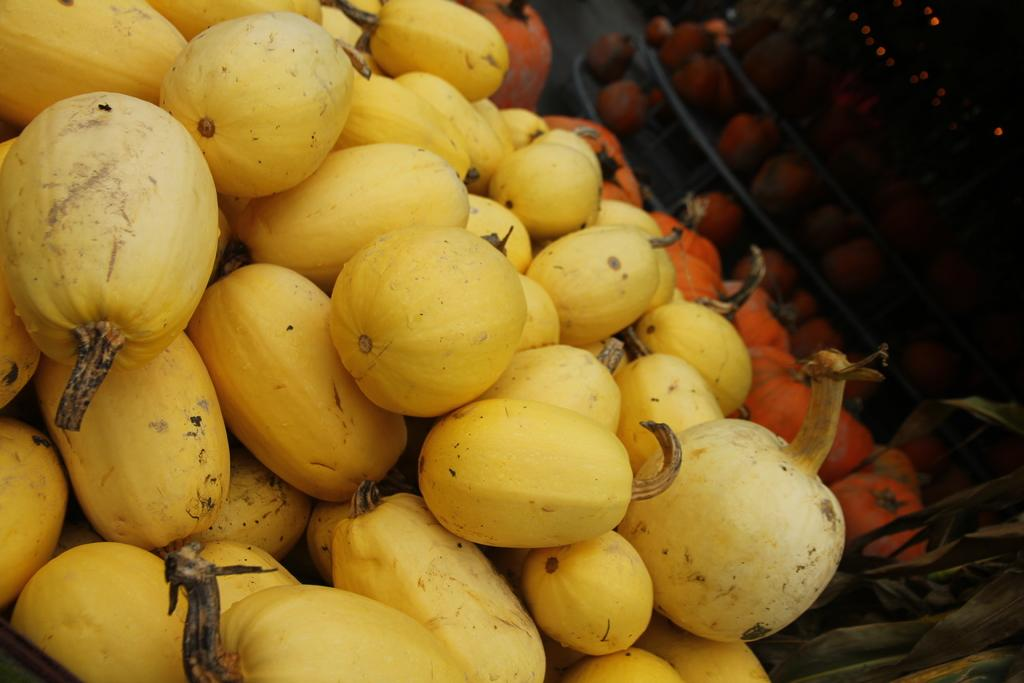What objects are present in the picture? There are pumpkins in the picture. What colors are the pumpkins? The pumpkins are red and yellow in color. What can be observed about the background of the image? The background of the image is dark. How many legs does the ladybug have in the image? There is no ladybug present in the image, so it is not possible to determine the number of legs it might have. 